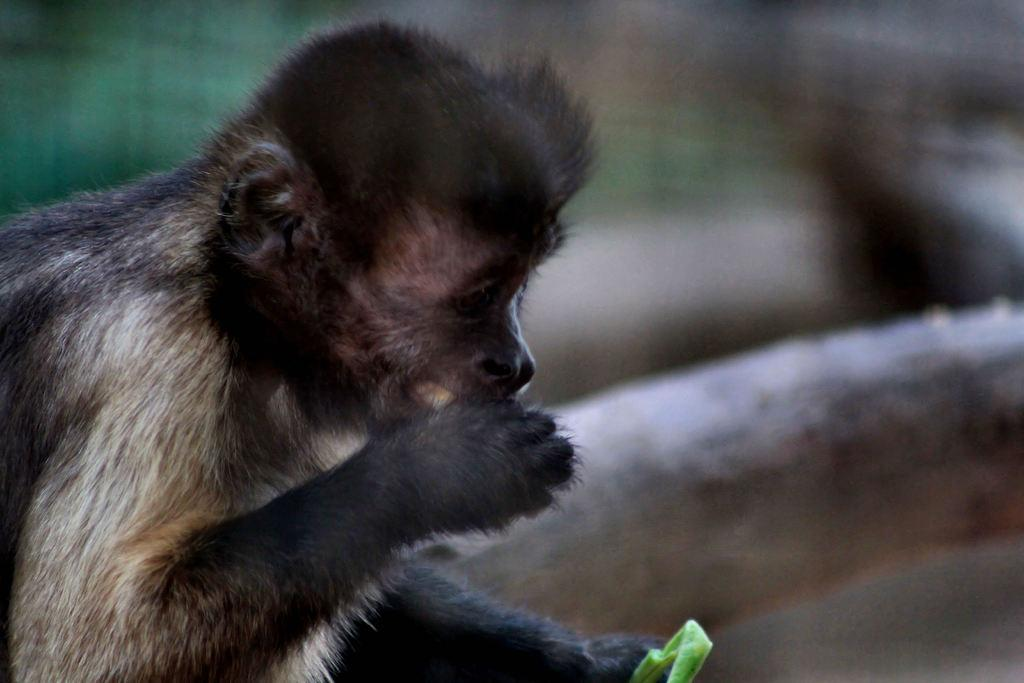What type of animal is present in the image? There is a monkey in the image. What type of bread is being served at the current place in the image? There is no bread or place mentioned in the image; it only features a monkey. 